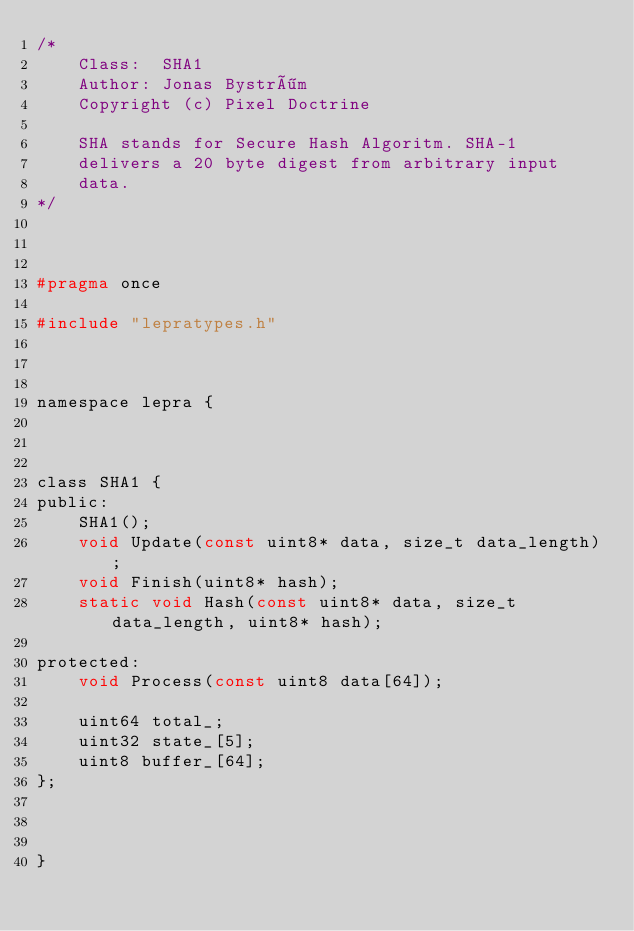<code> <loc_0><loc_0><loc_500><loc_500><_C_>/*
	Class:  SHA1
	Author: Jonas Byström
	Copyright (c) Pixel Doctrine

	SHA stands for Secure Hash Algoritm. SHA-1
	delivers a 20 byte digest from arbitrary input
	data.
*/



#pragma once

#include "lepratypes.h"



namespace lepra {



class SHA1 {
public:
	SHA1();
	void Update(const uint8* data, size_t data_length);
	void Finish(uint8* hash);
	static void Hash(const uint8* data, size_t data_length, uint8* hash);

protected:
	void Process(const uint8 data[64]);

	uint64 total_;
	uint32 state_[5];
	uint8 buffer_[64];
};



}
</code> 